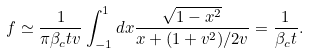Convert formula to latex. <formula><loc_0><loc_0><loc_500><loc_500>f \simeq \frac { 1 } { \pi \beta _ { c } t v } \int _ { - 1 } ^ { 1 } d x \frac { \sqrt { 1 - x ^ { 2 } } } { x + ( 1 + v ^ { 2 } ) / 2 v } = \frac { 1 } { \beta _ { c } t } .</formula> 